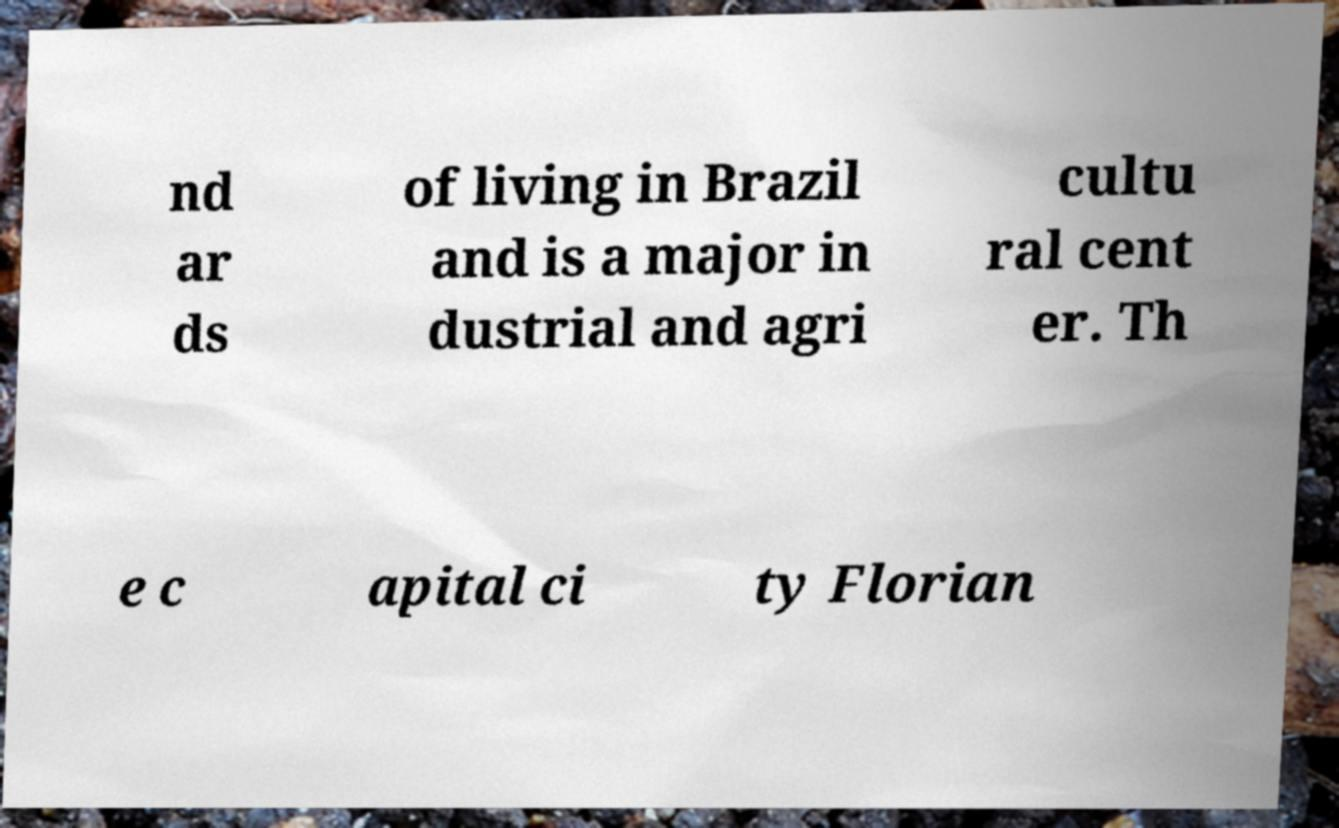For documentation purposes, I need the text within this image transcribed. Could you provide that? nd ar ds of living in Brazil and is a major in dustrial and agri cultu ral cent er. Th e c apital ci ty Florian 